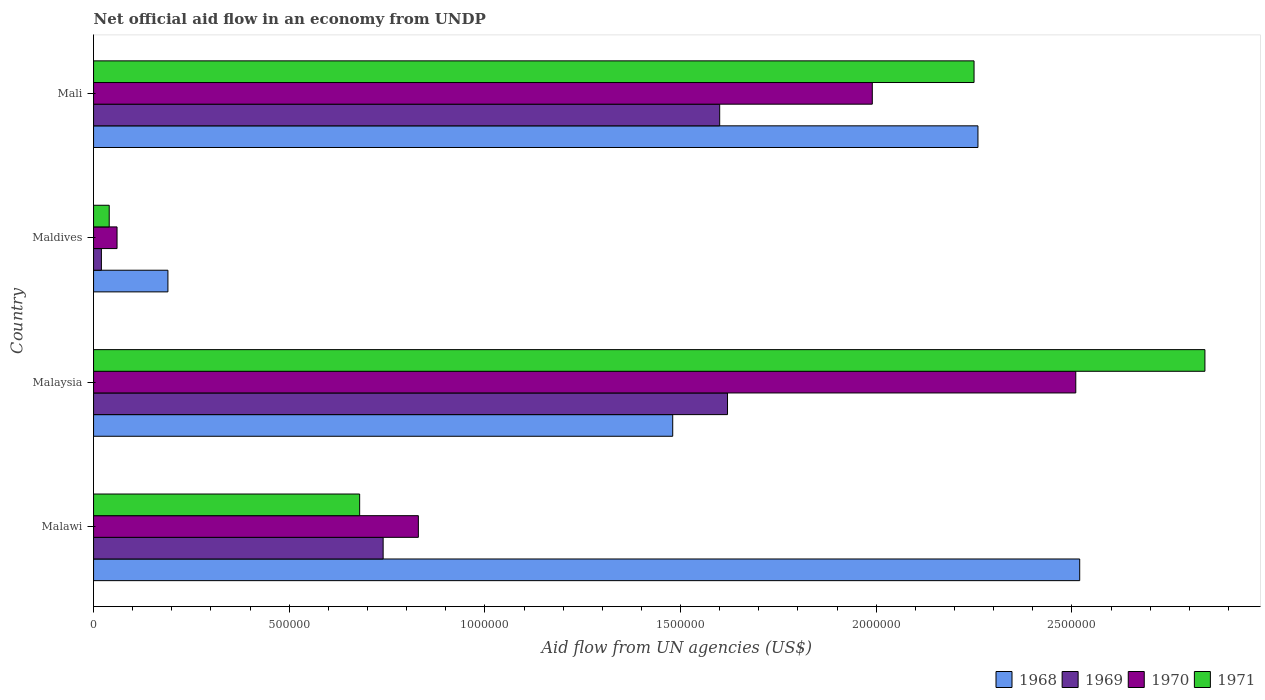How many bars are there on the 3rd tick from the top?
Provide a succinct answer. 4. How many bars are there on the 2nd tick from the bottom?
Provide a short and direct response. 4. What is the label of the 4th group of bars from the top?
Keep it short and to the point. Malawi. What is the net official aid flow in 1971 in Mali?
Your response must be concise. 2.25e+06. Across all countries, what is the maximum net official aid flow in 1971?
Offer a very short reply. 2.84e+06. In which country was the net official aid flow in 1971 maximum?
Your response must be concise. Malaysia. In which country was the net official aid flow in 1970 minimum?
Make the answer very short. Maldives. What is the total net official aid flow in 1970 in the graph?
Your answer should be very brief. 5.39e+06. What is the difference between the net official aid flow in 1968 in Malaysia and that in Mali?
Provide a short and direct response. -7.80e+05. What is the difference between the net official aid flow in 1971 in Maldives and the net official aid flow in 1968 in Mali?
Offer a very short reply. -2.22e+06. What is the average net official aid flow in 1969 per country?
Keep it short and to the point. 9.95e+05. What is the difference between the net official aid flow in 1969 and net official aid flow in 1970 in Maldives?
Provide a short and direct response. -4.00e+04. What is the ratio of the net official aid flow in 1968 in Malawi to that in Malaysia?
Your answer should be very brief. 1.7. What is the difference between the highest and the second highest net official aid flow in 1971?
Offer a terse response. 5.90e+05. What is the difference between the highest and the lowest net official aid flow in 1971?
Keep it short and to the point. 2.80e+06. In how many countries, is the net official aid flow in 1968 greater than the average net official aid flow in 1968 taken over all countries?
Provide a short and direct response. 2. What does the 1st bar from the top in Mali represents?
Keep it short and to the point. 1971. What does the 1st bar from the bottom in Malawi represents?
Keep it short and to the point. 1968. Are all the bars in the graph horizontal?
Your answer should be very brief. Yes. Are the values on the major ticks of X-axis written in scientific E-notation?
Ensure brevity in your answer.  No. How many legend labels are there?
Offer a terse response. 4. What is the title of the graph?
Provide a short and direct response. Net official aid flow in an economy from UNDP. Does "1995" appear as one of the legend labels in the graph?
Provide a short and direct response. No. What is the label or title of the X-axis?
Provide a succinct answer. Aid flow from UN agencies (US$). What is the Aid flow from UN agencies (US$) of 1968 in Malawi?
Your answer should be compact. 2.52e+06. What is the Aid flow from UN agencies (US$) of 1969 in Malawi?
Ensure brevity in your answer.  7.40e+05. What is the Aid flow from UN agencies (US$) of 1970 in Malawi?
Your answer should be compact. 8.30e+05. What is the Aid flow from UN agencies (US$) in 1971 in Malawi?
Your answer should be very brief. 6.80e+05. What is the Aid flow from UN agencies (US$) in 1968 in Malaysia?
Offer a terse response. 1.48e+06. What is the Aid flow from UN agencies (US$) of 1969 in Malaysia?
Give a very brief answer. 1.62e+06. What is the Aid flow from UN agencies (US$) of 1970 in Malaysia?
Give a very brief answer. 2.51e+06. What is the Aid flow from UN agencies (US$) of 1971 in Malaysia?
Ensure brevity in your answer.  2.84e+06. What is the Aid flow from UN agencies (US$) in 1968 in Maldives?
Make the answer very short. 1.90e+05. What is the Aid flow from UN agencies (US$) in 1969 in Maldives?
Ensure brevity in your answer.  2.00e+04. What is the Aid flow from UN agencies (US$) of 1970 in Maldives?
Offer a terse response. 6.00e+04. What is the Aid flow from UN agencies (US$) of 1971 in Maldives?
Make the answer very short. 4.00e+04. What is the Aid flow from UN agencies (US$) in 1968 in Mali?
Your answer should be compact. 2.26e+06. What is the Aid flow from UN agencies (US$) of 1969 in Mali?
Keep it short and to the point. 1.60e+06. What is the Aid flow from UN agencies (US$) of 1970 in Mali?
Your response must be concise. 1.99e+06. What is the Aid flow from UN agencies (US$) of 1971 in Mali?
Offer a very short reply. 2.25e+06. Across all countries, what is the maximum Aid flow from UN agencies (US$) in 1968?
Your answer should be very brief. 2.52e+06. Across all countries, what is the maximum Aid flow from UN agencies (US$) in 1969?
Give a very brief answer. 1.62e+06. Across all countries, what is the maximum Aid flow from UN agencies (US$) in 1970?
Offer a terse response. 2.51e+06. Across all countries, what is the maximum Aid flow from UN agencies (US$) in 1971?
Make the answer very short. 2.84e+06. Across all countries, what is the minimum Aid flow from UN agencies (US$) of 1969?
Your answer should be very brief. 2.00e+04. Across all countries, what is the minimum Aid flow from UN agencies (US$) of 1970?
Keep it short and to the point. 6.00e+04. What is the total Aid flow from UN agencies (US$) in 1968 in the graph?
Provide a short and direct response. 6.45e+06. What is the total Aid flow from UN agencies (US$) in 1969 in the graph?
Provide a succinct answer. 3.98e+06. What is the total Aid flow from UN agencies (US$) of 1970 in the graph?
Your answer should be compact. 5.39e+06. What is the total Aid flow from UN agencies (US$) of 1971 in the graph?
Ensure brevity in your answer.  5.81e+06. What is the difference between the Aid flow from UN agencies (US$) in 1968 in Malawi and that in Malaysia?
Give a very brief answer. 1.04e+06. What is the difference between the Aid flow from UN agencies (US$) in 1969 in Malawi and that in Malaysia?
Give a very brief answer. -8.80e+05. What is the difference between the Aid flow from UN agencies (US$) in 1970 in Malawi and that in Malaysia?
Your answer should be very brief. -1.68e+06. What is the difference between the Aid flow from UN agencies (US$) of 1971 in Malawi and that in Malaysia?
Provide a succinct answer. -2.16e+06. What is the difference between the Aid flow from UN agencies (US$) of 1968 in Malawi and that in Maldives?
Your answer should be compact. 2.33e+06. What is the difference between the Aid flow from UN agencies (US$) in 1969 in Malawi and that in Maldives?
Your response must be concise. 7.20e+05. What is the difference between the Aid flow from UN agencies (US$) of 1970 in Malawi and that in Maldives?
Provide a short and direct response. 7.70e+05. What is the difference between the Aid flow from UN agencies (US$) of 1971 in Malawi and that in Maldives?
Ensure brevity in your answer.  6.40e+05. What is the difference between the Aid flow from UN agencies (US$) in 1969 in Malawi and that in Mali?
Your answer should be compact. -8.60e+05. What is the difference between the Aid flow from UN agencies (US$) in 1970 in Malawi and that in Mali?
Provide a short and direct response. -1.16e+06. What is the difference between the Aid flow from UN agencies (US$) in 1971 in Malawi and that in Mali?
Your response must be concise. -1.57e+06. What is the difference between the Aid flow from UN agencies (US$) in 1968 in Malaysia and that in Maldives?
Provide a succinct answer. 1.29e+06. What is the difference between the Aid flow from UN agencies (US$) of 1969 in Malaysia and that in Maldives?
Your response must be concise. 1.60e+06. What is the difference between the Aid flow from UN agencies (US$) in 1970 in Malaysia and that in Maldives?
Offer a terse response. 2.45e+06. What is the difference between the Aid flow from UN agencies (US$) of 1971 in Malaysia and that in Maldives?
Ensure brevity in your answer.  2.80e+06. What is the difference between the Aid flow from UN agencies (US$) in 1968 in Malaysia and that in Mali?
Offer a terse response. -7.80e+05. What is the difference between the Aid flow from UN agencies (US$) in 1969 in Malaysia and that in Mali?
Your answer should be compact. 2.00e+04. What is the difference between the Aid flow from UN agencies (US$) in 1970 in Malaysia and that in Mali?
Give a very brief answer. 5.20e+05. What is the difference between the Aid flow from UN agencies (US$) of 1971 in Malaysia and that in Mali?
Keep it short and to the point. 5.90e+05. What is the difference between the Aid flow from UN agencies (US$) in 1968 in Maldives and that in Mali?
Provide a succinct answer. -2.07e+06. What is the difference between the Aid flow from UN agencies (US$) in 1969 in Maldives and that in Mali?
Make the answer very short. -1.58e+06. What is the difference between the Aid flow from UN agencies (US$) in 1970 in Maldives and that in Mali?
Keep it short and to the point. -1.93e+06. What is the difference between the Aid flow from UN agencies (US$) of 1971 in Maldives and that in Mali?
Ensure brevity in your answer.  -2.21e+06. What is the difference between the Aid flow from UN agencies (US$) in 1968 in Malawi and the Aid flow from UN agencies (US$) in 1969 in Malaysia?
Provide a succinct answer. 9.00e+05. What is the difference between the Aid flow from UN agencies (US$) in 1968 in Malawi and the Aid flow from UN agencies (US$) in 1970 in Malaysia?
Provide a short and direct response. 10000. What is the difference between the Aid flow from UN agencies (US$) of 1968 in Malawi and the Aid flow from UN agencies (US$) of 1971 in Malaysia?
Keep it short and to the point. -3.20e+05. What is the difference between the Aid flow from UN agencies (US$) of 1969 in Malawi and the Aid flow from UN agencies (US$) of 1970 in Malaysia?
Provide a succinct answer. -1.77e+06. What is the difference between the Aid flow from UN agencies (US$) in 1969 in Malawi and the Aid flow from UN agencies (US$) in 1971 in Malaysia?
Make the answer very short. -2.10e+06. What is the difference between the Aid flow from UN agencies (US$) of 1970 in Malawi and the Aid flow from UN agencies (US$) of 1971 in Malaysia?
Give a very brief answer. -2.01e+06. What is the difference between the Aid flow from UN agencies (US$) in 1968 in Malawi and the Aid flow from UN agencies (US$) in 1969 in Maldives?
Your answer should be compact. 2.50e+06. What is the difference between the Aid flow from UN agencies (US$) of 1968 in Malawi and the Aid flow from UN agencies (US$) of 1970 in Maldives?
Provide a succinct answer. 2.46e+06. What is the difference between the Aid flow from UN agencies (US$) in 1968 in Malawi and the Aid flow from UN agencies (US$) in 1971 in Maldives?
Offer a very short reply. 2.48e+06. What is the difference between the Aid flow from UN agencies (US$) of 1969 in Malawi and the Aid flow from UN agencies (US$) of 1970 in Maldives?
Keep it short and to the point. 6.80e+05. What is the difference between the Aid flow from UN agencies (US$) of 1969 in Malawi and the Aid flow from UN agencies (US$) of 1971 in Maldives?
Your response must be concise. 7.00e+05. What is the difference between the Aid flow from UN agencies (US$) in 1970 in Malawi and the Aid flow from UN agencies (US$) in 1971 in Maldives?
Your answer should be compact. 7.90e+05. What is the difference between the Aid flow from UN agencies (US$) in 1968 in Malawi and the Aid flow from UN agencies (US$) in 1969 in Mali?
Keep it short and to the point. 9.20e+05. What is the difference between the Aid flow from UN agencies (US$) of 1968 in Malawi and the Aid flow from UN agencies (US$) of 1970 in Mali?
Offer a very short reply. 5.30e+05. What is the difference between the Aid flow from UN agencies (US$) of 1969 in Malawi and the Aid flow from UN agencies (US$) of 1970 in Mali?
Provide a succinct answer. -1.25e+06. What is the difference between the Aid flow from UN agencies (US$) of 1969 in Malawi and the Aid flow from UN agencies (US$) of 1971 in Mali?
Ensure brevity in your answer.  -1.51e+06. What is the difference between the Aid flow from UN agencies (US$) of 1970 in Malawi and the Aid flow from UN agencies (US$) of 1971 in Mali?
Offer a very short reply. -1.42e+06. What is the difference between the Aid flow from UN agencies (US$) of 1968 in Malaysia and the Aid flow from UN agencies (US$) of 1969 in Maldives?
Make the answer very short. 1.46e+06. What is the difference between the Aid flow from UN agencies (US$) of 1968 in Malaysia and the Aid flow from UN agencies (US$) of 1970 in Maldives?
Ensure brevity in your answer.  1.42e+06. What is the difference between the Aid flow from UN agencies (US$) in 1968 in Malaysia and the Aid flow from UN agencies (US$) in 1971 in Maldives?
Provide a short and direct response. 1.44e+06. What is the difference between the Aid flow from UN agencies (US$) in 1969 in Malaysia and the Aid flow from UN agencies (US$) in 1970 in Maldives?
Make the answer very short. 1.56e+06. What is the difference between the Aid flow from UN agencies (US$) of 1969 in Malaysia and the Aid flow from UN agencies (US$) of 1971 in Maldives?
Keep it short and to the point. 1.58e+06. What is the difference between the Aid flow from UN agencies (US$) in 1970 in Malaysia and the Aid flow from UN agencies (US$) in 1971 in Maldives?
Ensure brevity in your answer.  2.47e+06. What is the difference between the Aid flow from UN agencies (US$) of 1968 in Malaysia and the Aid flow from UN agencies (US$) of 1969 in Mali?
Make the answer very short. -1.20e+05. What is the difference between the Aid flow from UN agencies (US$) in 1968 in Malaysia and the Aid flow from UN agencies (US$) in 1970 in Mali?
Your response must be concise. -5.10e+05. What is the difference between the Aid flow from UN agencies (US$) of 1968 in Malaysia and the Aid flow from UN agencies (US$) of 1971 in Mali?
Provide a short and direct response. -7.70e+05. What is the difference between the Aid flow from UN agencies (US$) in 1969 in Malaysia and the Aid flow from UN agencies (US$) in 1970 in Mali?
Your response must be concise. -3.70e+05. What is the difference between the Aid flow from UN agencies (US$) of 1969 in Malaysia and the Aid flow from UN agencies (US$) of 1971 in Mali?
Give a very brief answer. -6.30e+05. What is the difference between the Aid flow from UN agencies (US$) in 1970 in Malaysia and the Aid flow from UN agencies (US$) in 1971 in Mali?
Give a very brief answer. 2.60e+05. What is the difference between the Aid flow from UN agencies (US$) of 1968 in Maldives and the Aid flow from UN agencies (US$) of 1969 in Mali?
Ensure brevity in your answer.  -1.41e+06. What is the difference between the Aid flow from UN agencies (US$) of 1968 in Maldives and the Aid flow from UN agencies (US$) of 1970 in Mali?
Your answer should be very brief. -1.80e+06. What is the difference between the Aid flow from UN agencies (US$) in 1968 in Maldives and the Aid flow from UN agencies (US$) in 1971 in Mali?
Your answer should be very brief. -2.06e+06. What is the difference between the Aid flow from UN agencies (US$) of 1969 in Maldives and the Aid flow from UN agencies (US$) of 1970 in Mali?
Provide a succinct answer. -1.97e+06. What is the difference between the Aid flow from UN agencies (US$) in 1969 in Maldives and the Aid flow from UN agencies (US$) in 1971 in Mali?
Offer a terse response. -2.23e+06. What is the difference between the Aid flow from UN agencies (US$) of 1970 in Maldives and the Aid flow from UN agencies (US$) of 1971 in Mali?
Your response must be concise. -2.19e+06. What is the average Aid flow from UN agencies (US$) of 1968 per country?
Provide a succinct answer. 1.61e+06. What is the average Aid flow from UN agencies (US$) of 1969 per country?
Your answer should be compact. 9.95e+05. What is the average Aid flow from UN agencies (US$) of 1970 per country?
Offer a very short reply. 1.35e+06. What is the average Aid flow from UN agencies (US$) of 1971 per country?
Make the answer very short. 1.45e+06. What is the difference between the Aid flow from UN agencies (US$) of 1968 and Aid flow from UN agencies (US$) of 1969 in Malawi?
Offer a very short reply. 1.78e+06. What is the difference between the Aid flow from UN agencies (US$) in 1968 and Aid flow from UN agencies (US$) in 1970 in Malawi?
Your response must be concise. 1.69e+06. What is the difference between the Aid flow from UN agencies (US$) of 1968 and Aid flow from UN agencies (US$) of 1971 in Malawi?
Your response must be concise. 1.84e+06. What is the difference between the Aid flow from UN agencies (US$) of 1969 and Aid flow from UN agencies (US$) of 1970 in Malawi?
Make the answer very short. -9.00e+04. What is the difference between the Aid flow from UN agencies (US$) of 1969 and Aid flow from UN agencies (US$) of 1971 in Malawi?
Offer a very short reply. 6.00e+04. What is the difference between the Aid flow from UN agencies (US$) in 1970 and Aid flow from UN agencies (US$) in 1971 in Malawi?
Give a very brief answer. 1.50e+05. What is the difference between the Aid flow from UN agencies (US$) of 1968 and Aid flow from UN agencies (US$) of 1970 in Malaysia?
Your answer should be compact. -1.03e+06. What is the difference between the Aid flow from UN agencies (US$) in 1968 and Aid flow from UN agencies (US$) in 1971 in Malaysia?
Your answer should be very brief. -1.36e+06. What is the difference between the Aid flow from UN agencies (US$) in 1969 and Aid flow from UN agencies (US$) in 1970 in Malaysia?
Your response must be concise. -8.90e+05. What is the difference between the Aid flow from UN agencies (US$) in 1969 and Aid flow from UN agencies (US$) in 1971 in Malaysia?
Your response must be concise. -1.22e+06. What is the difference between the Aid flow from UN agencies (US$) of 1970 and Aid flow from UN agencies (US$) of 1971 in Malaysia?
Provide a short and direct response. -3.30e+05. What is the difference between the Aid flow from UN agencies (US$) of 1968 and Aid flow from UN agencies (US$) of 1969 in Maldives?
Your response must be concise. 1.70e+05. What is the difference between the Aid flow from UN agencies (US$) of 1968 and Aid flow from UN agencies (US$) of 1971 in Maldives?
Keep it short and to the point. 1.50e+05. What is the difference between the Aid flow from UN agencies (US$) of 1969 and Aid flow from UN agencies (US$) of 1971 in Maldives?
Make the answer very short. -2.00e+04. What is the difference between the Aid flow from UN agencies (US$) of 1970 and Aid flow from UN agencies (US$) of 1971 in Maldives?
Ensure brevity in your answer.  2.00e+04. What is the difference between the Aid flow from UN agencies (US$) in 1968 and Aid flow from UN agencies (US$) in 1970 in Mali?
Make the answer very short. 2.70e+05. What is the difference between the Aid flow from UN agencies (US$) in 1968 and Aid flow from UN agencies (US$) in 1971 in Mali?
Offer a very short reply. 10000. What is the difference between the Aid flow from UN agencies (US$) in 1969 and Aid flow from UN agencies (US$) in 1970 in Mali?
Ensure brevity in your answer.  -3.90e+05. What is the difference between the Aid flow from UN agencies (US$) of 1969 and Aid flow from UN agencies (US$) of 1971 in Mali?
Make the answer very short. -6.50e+05. What is the difference between the Aid flow from UN agencies (US$) in 1970 and Aid flow from UN agencies (US$) in 1971 in Mali?
Your answer should be very brief. -2.60e+05. What is the ratio of the Aid flow from UN agencies (US$) in 1968 in Malawi to that in Malaysia?
Your response must be concise. 1.7. What is the ratio of the Aid flow from UN agencies (US$) of 1969 in Malawi to that in Malaysia?
Your answer should be compact. 0.46. What is the ratio of the Aid flow from UN agencies (US$) of 1970 in Malawi to that in Malaysia?
Provide a succinct answer. 0.33. What is the ratio of the Aid flow from UN agencies (US$) of 1971 in Malawi to that in Malaysia?
Keep it short and to the point. 0.24. What is the ratio of the Aid flow from UN agencies (US$) in 1968 in Malawi to that in Maldives?
Offer a very short reply. 13.26. What is the ratio of the Aid flow from UN agencies (US$) of 1969 in Malawi to that in Maldives?
Give a very brief answer. 37. What is the ratio of the Aid flow from UN agencies (US$) in 1970 in Malawi to that in Maldives?
Keep it short and to the point. 13.83. What is the ratio of the Aid flow from UN agencies (US$) in 1971 in Malawi to that in Maldives?
Your response must be concise. 17. What is the ratio of the Aid flow from UN agencies (US$) in 1968 in Malawi to that in Mali?
Offer a terse response. 1.11. What is the ratio of the Aid flow from UN agencies (US$) of 1969 in Malawi to that in Mali?
Offer a terse response. 0.46. What is the ratio of the Aid flow from UN agencies (US$) of 1970 in Malawi to that in Mali?
Your answer should be very brief. 0.42. What is the ratio of the Aid flow from UN agencies (US$) in 1971 in Malawi to that in Mali?
Provide a succinct answer. 0.3. What is the ratio of the Aid flow from UN agencies (US$) in 1968 in Malaysia to that in Maldives?
Ensure brevity in your answer.  7.79. What is the ratio of the Aid flow from UN agencies (US$) in 1969 in Malaysia to that in Maldives?
Offer a terse response. 81. What is the ratio of the Aid flow from UN agencies (US$) in 1970 in Malaysia to that in Maldives?
Make the answer very short. 41.83. What is the ratio of the Aid flow from UN agencies (US$) in 1971 in Malaysia to that in Maldives?
Offer a very short reply. 71. What is the ratio of the Aid flow from UN agencies (US$) in 1968 in Malaysia to that in Mali?
Provide a short and direct response. 0.65. What is the ratio of the Aid flow from UN agencies (US$) of 1969 in Malaysia to that in Mali?
Your response must be concise. 1.01. What is the ratio of the Aid flow from UN agencies (US$) in 1970 in Malaysia to that in Mali?
Offer a terse response. 1.26. What is the ratio of the Aid flow from UN agencies (US$) in 1971 in Malaysia to that in Mali?
Your answer should be very brief. 1.26. What is the ratio of the Aid flow from UN agencies (US$) of 1968 in Maldives to that in Mali?
Your answer should be compact. 0.08. What is the ratio of the Aid flow from UN agencies (US$) in 1969 in Maldives to that in Mali?
Offer a terse response. 0.01. What is the ratio of the Aid flow from UN agencies (US$) in 1970 in Maldives to that in Mali?
Offer a terse response. 0.03. What is the ratio of the Aid flow from UN agencies (US$) of 1971 in Maldives to that in Mali?
Ensure brevity in your answer.  0.02. What is the difference between the highest and the second highest Aid flow from UN agencies (US$) of 1968?
Make the answer very short. 2.60e+05. What is the difference between the highest and the second highest Aid flow from UN agencies (US$) in 1970?
Provide a short and direct response. 5.20e+05. What is the difference between the highest and the second highest Aid flow from UN agencies (US$) in 1971?
Ensure brevity in your answer.  5.90e+05. What is the difference between the highest and the lowest Aid flow from UN agencies (US$) of 1968?
Provide a short and direct response. 2.33e+06. What is the difference between the highest and the lowest Aid flow from UN agencies (US$) of 1969?
Give a very brief answer. 1.60e+06. What is the difference between the highest and the lowest Aid flow from UN agencies (US$) in 1970?
Give a very brief answer. 2.45e+06. What is the difference between the highest and the lowest Aid flow from UN agencies (US$) in 1971?
Provide a succinct answer. 2.80e+06. 